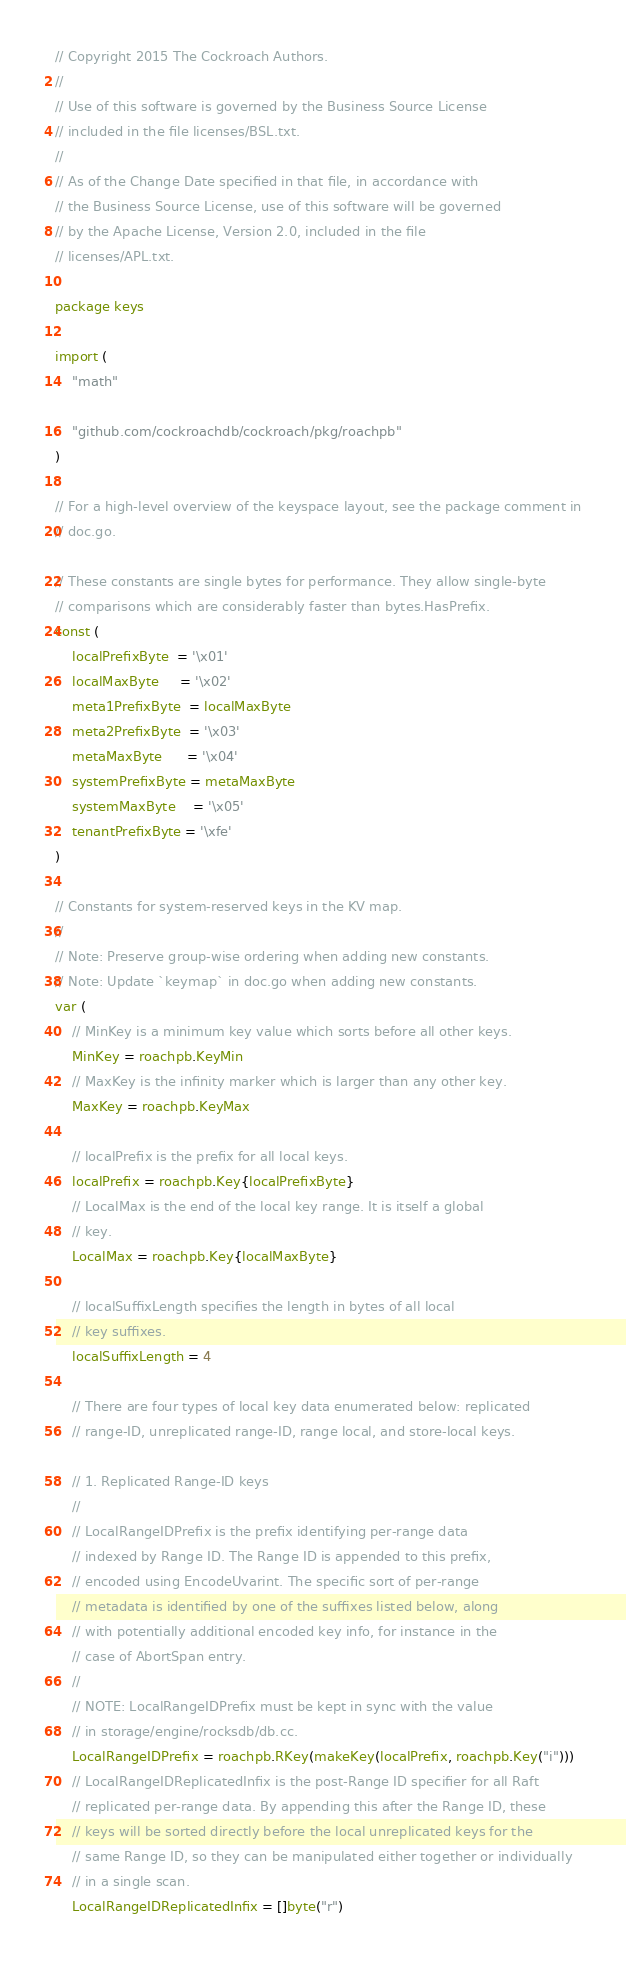<code> <loc_0><loc_0><loc_500><loc_500><_Go_>// Copyright 2015 The Cockroach Authors.
//
// Use of this software is governed by the Business Source License
// included in the file licenses/BSL.txt.
//
// As of the Change Date specified in that file, in accordance with
// the Business Source License, use of this software will be governed
// by the Apache License, Version 2.0, included in the file
// licenses/APL.txt.

package keys

import (
	"math"

	"github.com/cockroachdb/cockroach/pkg/roachpb"
)

// For a high-level overview of the keyspace layout, see the package comment in
// doc.go.

// These constants are single bytes for performance. They allow single-byte
// comparisons which are considerably faster than bytes.HasPrefix.
const (
	localPrefixByte  = '\x01'
	localMaxByte     = '\x02'
	meta1PrefixByte  = localMaxByte
	meta2PrefixByte  = '\x03'
	metaMaxByte      = '\x04'
	systemPrefixByte = metaMaxByte
	systemMaxByte    = '\x05'
	tenantPrefixByte = '\xfe'
)

// Constants for system-reserved keys in the KV map.
//
// Note: Preserve group-wise ordering when adding new constants.
// Note: Update `keymap` in doc.go when adding new constants.
var (
	// MinKey is a minimum key value which sorts before all other keys.
	MinKey = roachpb.KeyMin
	// MaxKey is the infinity marker which is larger than any other key.
	MaxKey = roachpb.KeyMax

	// localPrefix is the prefix for all local keys.
	localPrefix = roachpb.Key{localPrefixByte}
	// LocalMax is the end of the local key range. It is itself a global
	// key.
	LocalMax = roachpb.Key{localMaxByte}

	// localSuffixLength specifies the length in bytes of all local
	// key suffixes.
	localSuffixLength = 4

	// There are four types of local key data enumerated below: replicated
	// range-ID, unreplicated range-ID, range local, and store-local keys.

	// 1. Replicated Range-ID keys
	//
	// LocalRangeIDPrefix is the prefix identifying per-range data
	// indexed by Range ID. The Range ID is appended to this prefix,
	// encoded using EncodeUvarint. The specific sort of per-range
	// metadata is identified by one of the suffixes listed below, along
	// with potentially additional encoded key info, for instance in the
	// case of AbortSpan entry.
	//
	// NOTE: LocalRangeIDPrefix must be kept in sync with the value
	// in storage/engine/rocksdb/db.cc.
	LocalRangeIDPrefix = roachpb.RKey(makeKey(localPrefix, roachpb.Key("i")))
	// LocalRangeIDReplicatedInfix is the post-Range ID specifier for all Raft
	// replicated per-range data. By appending this after the Range ID, these
	// keys will be sorted directly before the local unreplicated keys for the
	// same Range ID, so they can be manipulated either together or individually
	// in a single scan.
	LocalRangeIDReplicatedInfix = []byte("r")</code> 